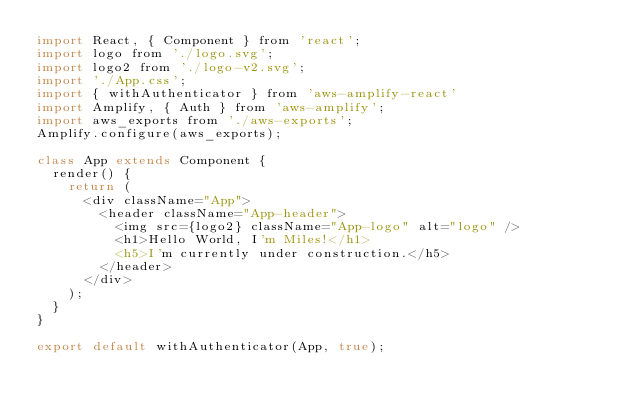Convert code to text. <code><loc_0><loc_0><loc_500><loc_500><_JavaScript_>import React, { Component } from 'react';
import logo from './logo.svg';
import logo2 from './logo-v2.svg';
import './App.css';
import { withAuthenticator } from 'aws-amplify-react'
import Amplify, { Auth } from 'aws-amplify';
import aws_exports from './aws-exports';
Amplify.configure(aws_exports);

class App extends Component {
  render() {
    return (
      <div className="App">
        <header className="App-header">
          <img src={logo2} className="App-logo" alt="logo" />
          <h1>Hello World, I'm Miles!</h1>
          <h5>I'm currently under construction.</h5>
        </header>
      </div>
    );
  }
}

export default withAuthenticator(App, true);
</code> 